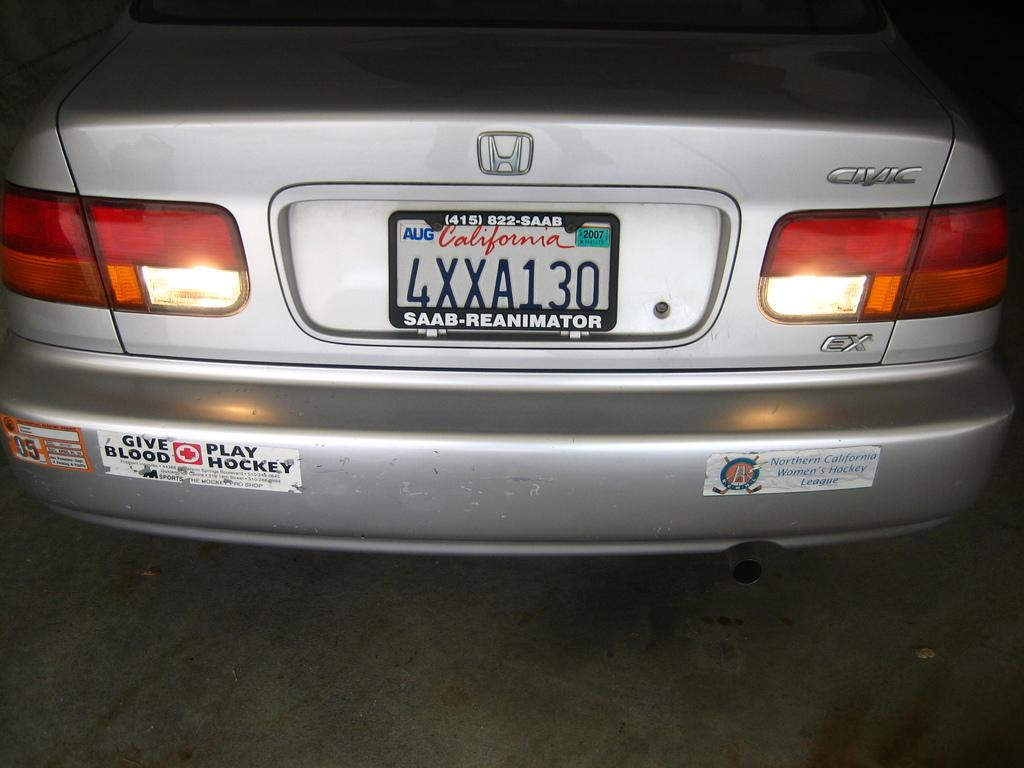<image>
Provide a brief description of the given image. A Honda Civic with a California license plate has bumper stickers on the back. 